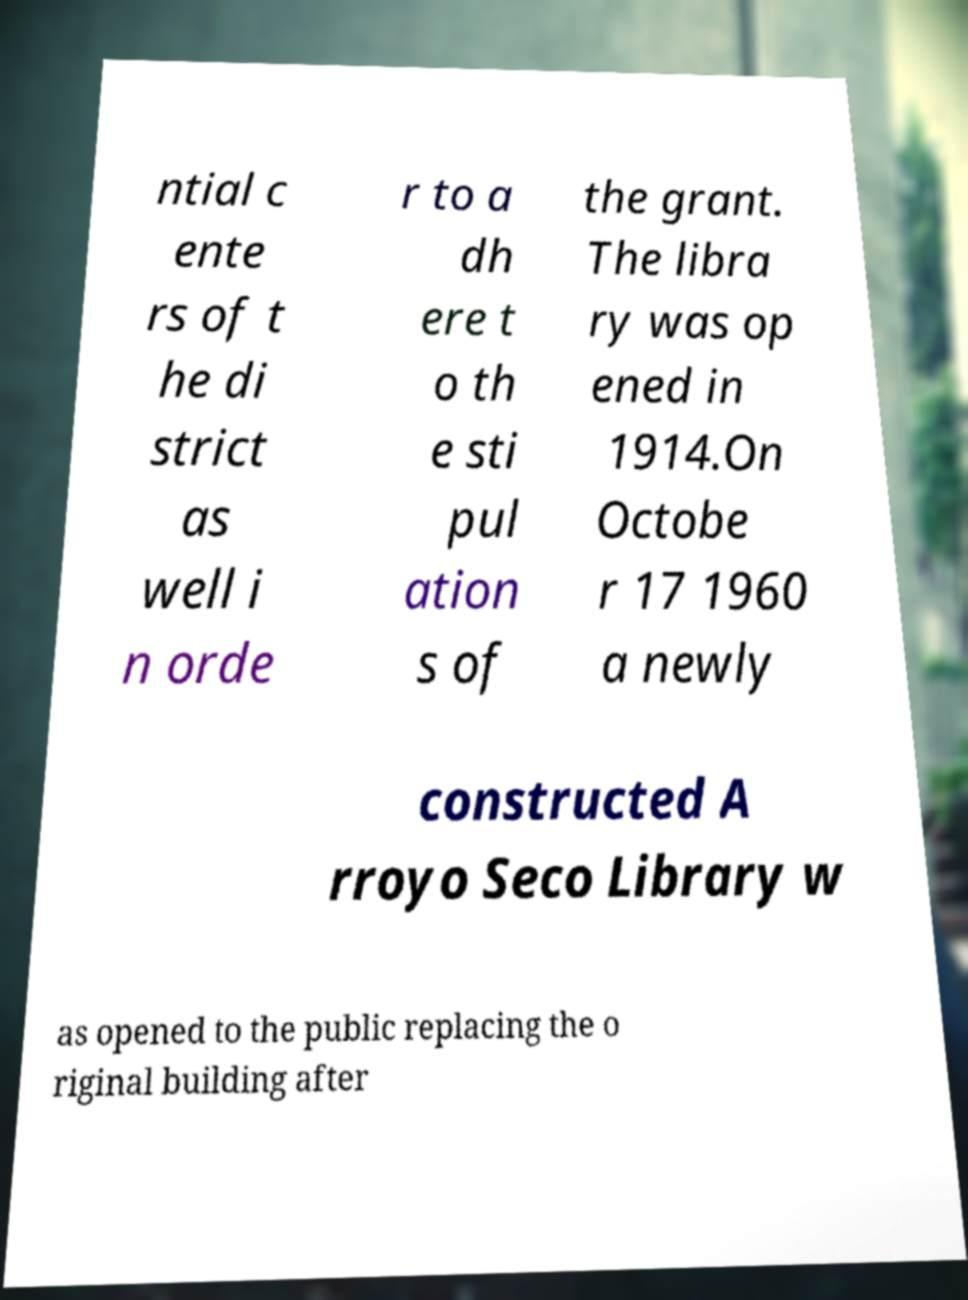Could you assist in decoding the text presented in this image and type it out clearly? ntial c ente rs of t he di strict as well i n orde r to a dh ere t o th e sti pul ation s of the grant. The libra ry was op ened in 1914.On Octobe r 17 1960 a newly constructed A rroyo Seco Library w as opened to the public replacing the o riginal building after 